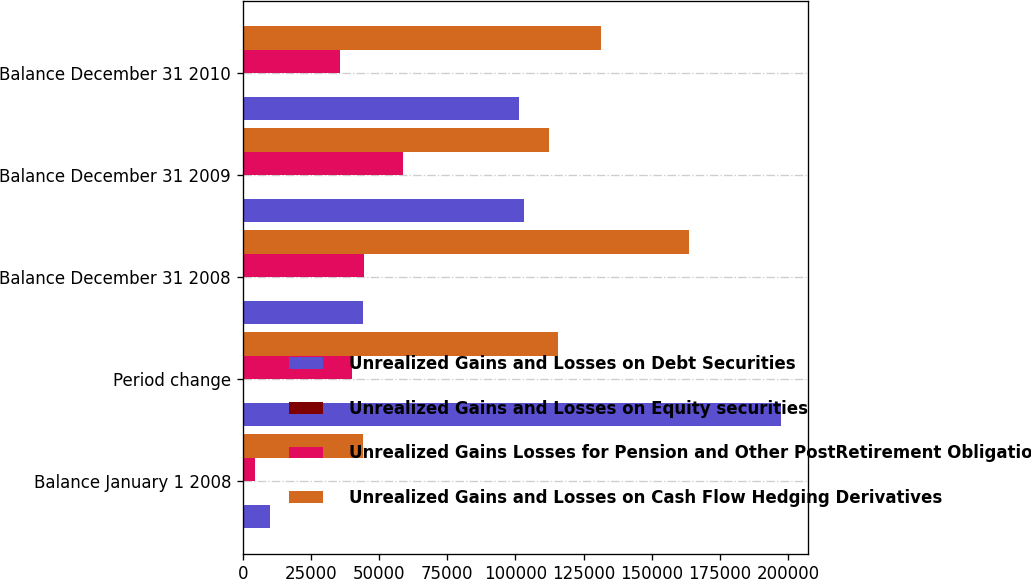<chart> <loc_0><loc_0><loc_500><loc_500><stacked_bar_chart><ecel><fcel>Balance January 1 2008<fcel>Period change<fcel>Balance December 31 2008<fcel>Balance December 31 2009<fcel>Balance December 31 2010<nl><fcel>Unrealized Gains and Losses on Debt Securities<fcel>10001<fcel>197426<fcel>44153<fcel>103060<fcel>101290<nl><fcel>Unrealized Gains and Losses on Equity securities<fcel>10<fcel>319<fcel>329<fcel>322<fcel>427<nl><fcel>Unrealized Gains Losses for Pension and Other PostRetirement Obligations<fcel>4553<fcel>40085<fcel>44638<fcel>58865<fcel>35710<nl><fcel>Unrealized Gains and Losses on Cash Flow Hedging Derivatives<fcel>44153<fcel>115588<fcel>163575<fcel>112468<fcel>131489<nl></chart> 